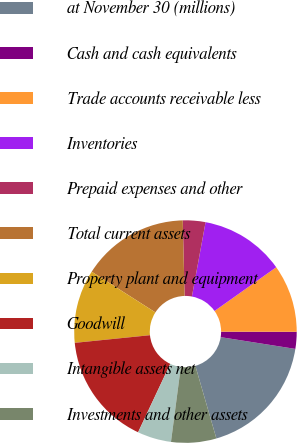Convert chart to OTSL. <chart><loc_0><loc_0><loc_500><loc_500><pie_chart><fcel>at November 30 (millions)<fcel>Cash and cash equivalents<fcel>Trade accounts receivable less<fcel>Inventories<fcel>Prepaid expenses and other<fcel>Total current assets<fcel>Property plant and equipment<fcel>Goodwill<fcel>Intangible assets net<fcel>Investments and other assets<nl><fcel>18.03%<fcel>2.46%<fcel>9.84%<fcel>12.29%<fcel>3.28%<fcel>15.57%<fcel>10.66%<fcel>16.39%<fcel>4.92%<fcel>6.56%<nl></chart> 